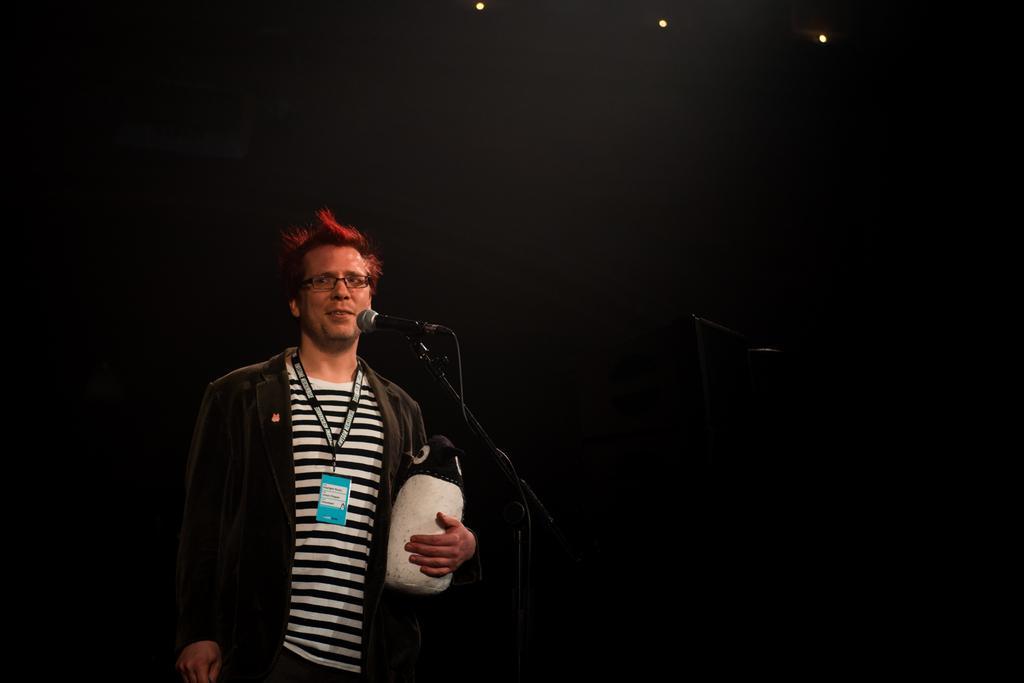How would you summarize this image in a sentence or two? In this image, I can see the man standing and holding an object in his hand. This is a mike with a mike stand. The background looks dark. At the top of the image, I think these are the lights. 